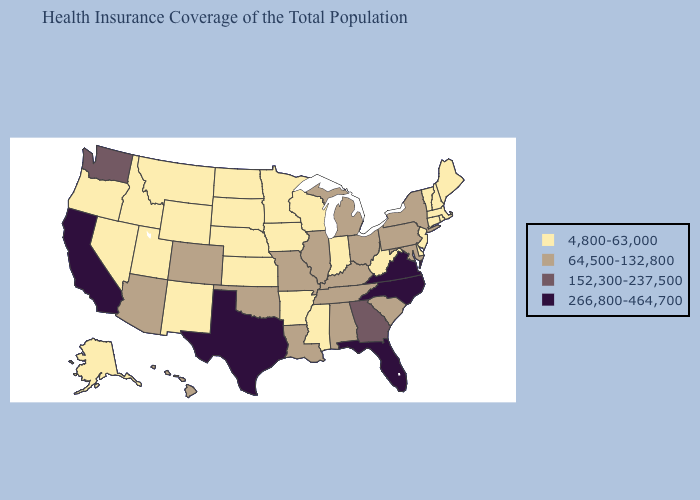What is the highest value in states that border New Hampshire?
Concise answer only. 4,800-63,000. What is the value of Kentucky?
Answer briefly. 64,500-132,800. Does Michigan have the lowest value in the MidWest?
Concise answer only. No. Which states have the highest value in the USA?
Quick response, please. California, Florida, North Carolina, Texas, Virginia. Name the states that have a value in the range 4,800-63,000?
Keep it brief. Alaska, Arkansas, Connecticut, Delaware, Idaho, Indiana, Iowa, Kansas, Maine, Massachusetts, Minnesota, Mississippi, Montana, Nebraska, Nevada, New Hampshire, New Jersey, New Mexico, North Dakota, Oregon, Rhode Island, South Dakota, Utah, Vermont, West Virginia, Wisconsin, Wyoming. What is the value of Arizona?
Write a very short answer. 64,500-132,800. Among the states that border Louisiana , which have the lowest value?
Concise answer only. Arkansas, Mississippi. What is the value of New Hampshire?
Give a very brief answer. 4,800-63,000. Does Vermont have the highest value in the Northeast?
Concise answer only. No. What is the highest value in the USA?
Answer briefly. 266,800-464,700. Name the states that have a value in the range 266,800-464,700?
Answer briefly. California, Florida, North Carolina, Texas, Virginia. What is the highest value in the West ?
Concise answer only. 266,800-464,700. Name the states that have a value in the range 4,800-63,000?
Answer briefly. Alaska, Arkansas, Connecticut, Delaware, Idaho, Indiana, Iowa, Kansas, Maine, Massachusetts, Minnesota, Mississippi, Montana, Nebraska, Nevada, New Hampshire, New Jersey, New Mexico, North Dakota, Oregon, Rhode Island, South Dakota, Utah, Vermont, West Virginia, Wisconsin, Wyoming. 